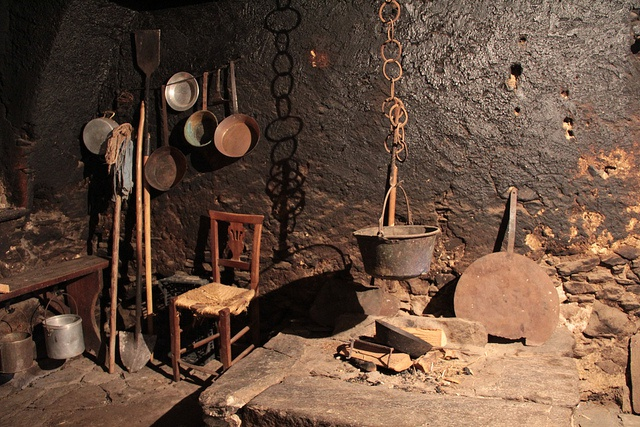Describe the objects in this image and their specific colors. I can see chair in black, maroon, tan, and brown tones, bench in black, maroon, and brown tones, and bowl in black, gray, and tan tones in this image. 